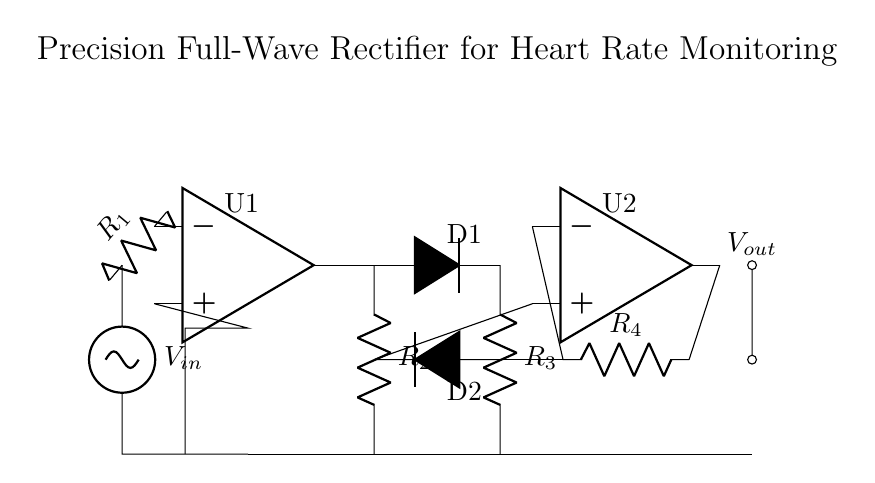What is the input voltage in this circuit? The input voltage is labeled as V in on the circuit diagram, indicating the source voltage that the circuit will process.
Answer: V in How many operational amplifiers are present? There are two operational amplifiers labeled U1 and U2 in the circuit diagram, which are used to facilitate the rectification process.
Answer: 2 What type of rectifier is illustrated in this circuit? The circuit is a precision full-wave rectifier, which allows both half cycles of the input signal to appear at the output, ensuring a consistent recovery of the signal.
Answer: Precision full-wave What is the purpose of the diodes in the circuit? The diodes D1 and D2 are used to provide the rectification function, allowing current to flow in one direction and thus converting the AC input signal into a DC output.
Answer: Rectification What is the relationship between output voltage and input voltage? The output voltage V out is a function of the input voltage V in, amplified and processed by the operational amplifiers, resulting in a rectified signal that tracks the input signal above zero volts.
Answer: V out = f(V in) Which components constitute the feedback path of U2? The feedback path for U2 includes resistor R4, which connects the output of U2 back to its inverting input, allowing proper operational amplifier functioning and gain control.
Answer: Resistor R4 How many resistors are utilized in the circuit? There are four resistors labeled R1, R2, R3, and R4 used to set the gain and feedback within the circuit, contributing to the precision of the rectification process.
Answer: 4 